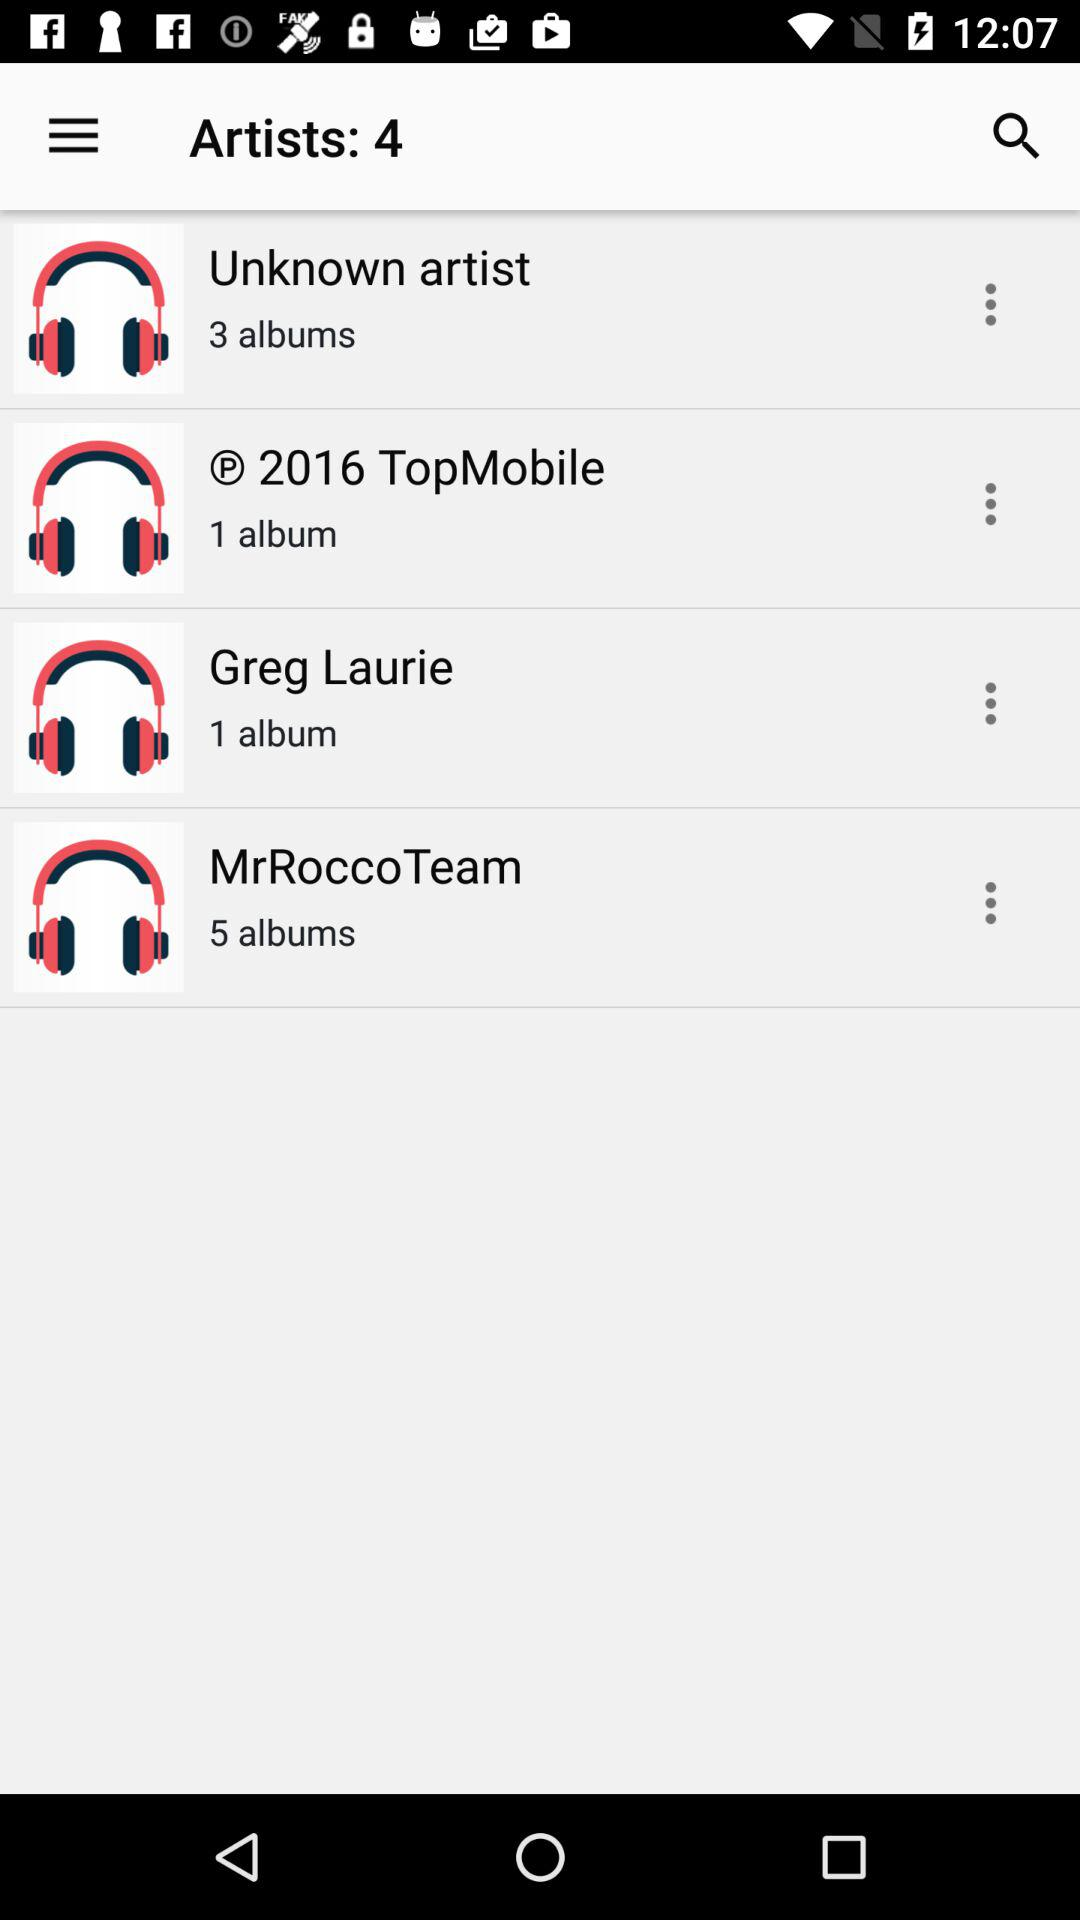How many more albums does MrRocco Team have than Unknown artist?
Answer the question using a single word or phrase. 2 